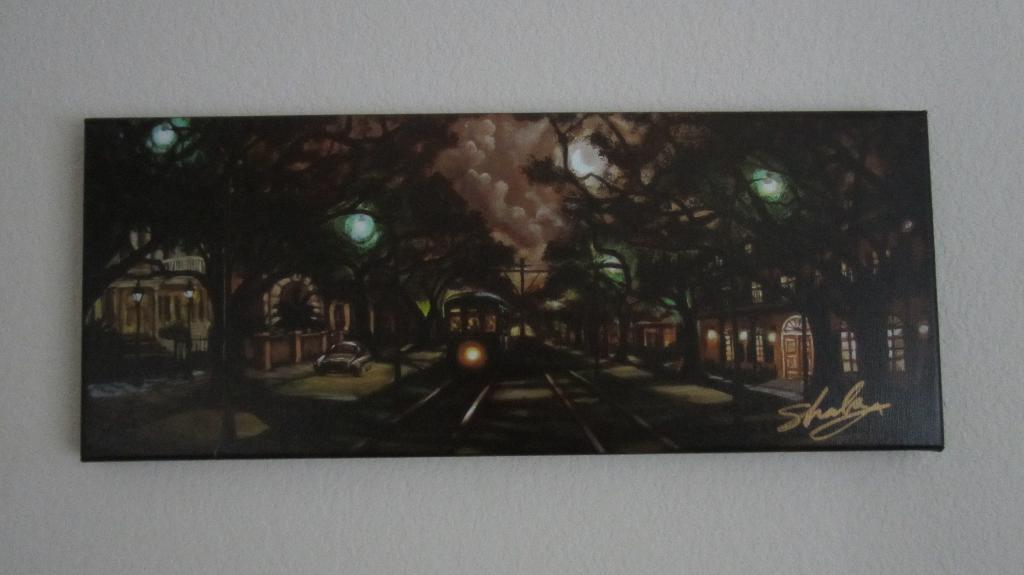What is the main object in the image? There is a painting frame in the image. Where is the painting frame located? The painting frame is hanging on a wall. What color is the wall where the painting frame is hanging? The wall is white. Can you see a friend rubbing a pig in the image? There is no friend or pig present in the image. 